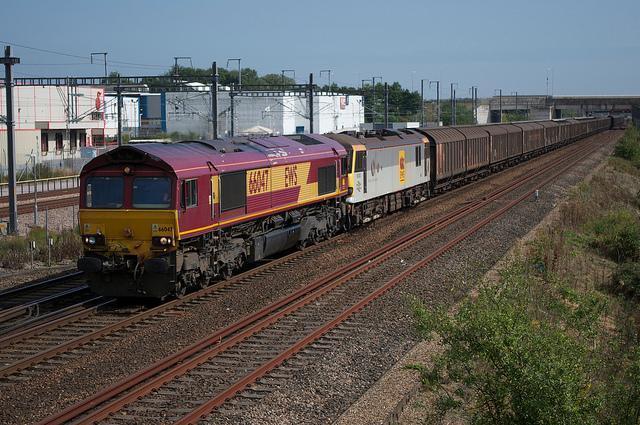How many trains can you see in the picture?
Give a very brief answer. 1. 